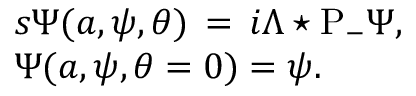Convert formula to latex. <formula><loc_0><loc_0><loc_500><loc_500>\begin{array} { l } { { { s \Psi ( a , \psi , \theta ) \, = \, i \Lambda ^ { * } P _ { - } \Psi , } } } \\ { \Psi ( a , \psi , \theta = 0 ) = \psi . } \end{array}</formula> 